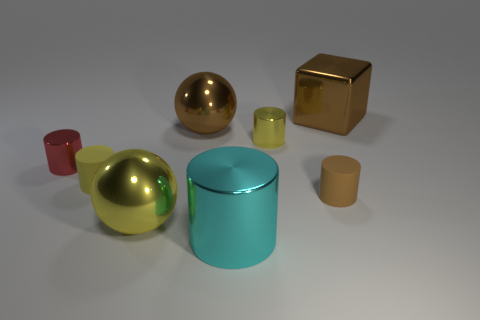There is a large shiny object that is left of the brown cylinder and behind the small red object; what shape is it?
Give a very brief answer. Sphere. What material is the big cyan object that is the same shape as the red object?
Offer a terse response. Metal. There is a large yellow metallic thing; does it have the same shape as the yellow metallic thing behind the small red metallic object?
Offer a terse response. No. How many matte objects are big brown cubes or cyan cylinders?
Your answer should be compact. 0. There is a sphere left of the large brown metallic object left of the brown metal cube that is behind the brown cylinder; what color is it?
Your response must be concise. Yellow. What number of other objects are there of the same material as the red cylinder?
Offer a very short reply. 5. Is the shape of the big brown thing in front of the large brown block the same as  the cyan metallic thing?
Offer a very short reply. No. How many small things are brown spheres or gray spheres?
Your answer should be compact. 0. Are there an equal number of yellow things behind the small yellow matte cylinder and big things that are in front of the red object?
Provide a succinct answer. No. What number of other things are the same color as the big block?
Give a very brief answer. 2. 